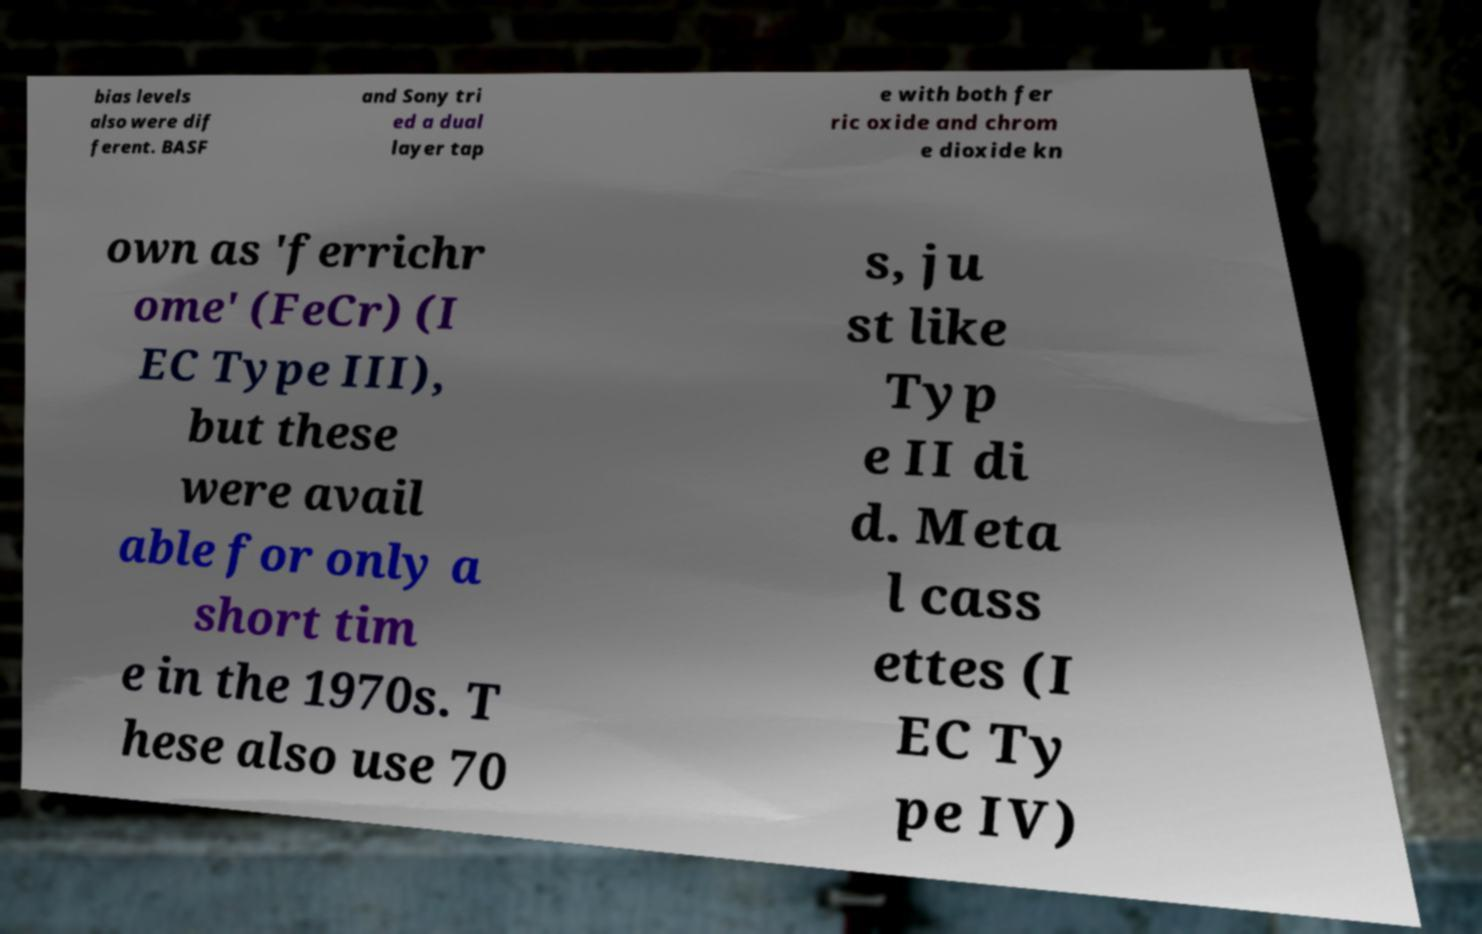What messages or text are displayed in this image? I need them in a readable, typed format. bias levels also were dif ferent. BASF and Sony tri ed a dual layer tap e with both fer ric oxide and chrom e dioxide kn own as 'ferrichr ome' (FeCr) (I EC Type III), but these were avail able for only a short tim e in the 1970s. T hese also use 70 s, ju st like Typ e II di d. Meta l cass ettes (I EC Ty pe IV) 